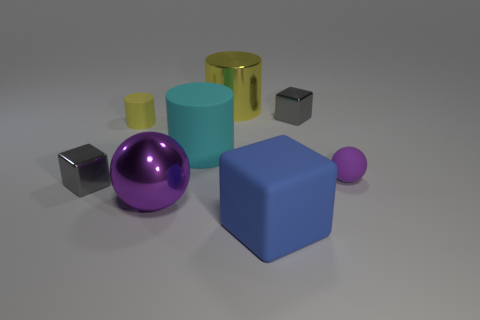Add 1 tiny yellow matte blocks. How many objects exist? 9 Subtract all cylinders. How many objects are left? 5 Add 7 big yellow cylinders. How many big yellow cylinders are left? 8 Add 3 tiny yellow rubber cylinders. How many tiny yellow rubber cylinders exist? 4 Subtract 2 gray blocks. How many objects are left? 6 Subtract all big yellow metal cylinders. Subtract all large blue rubber cubes. How many objects are left? 6 